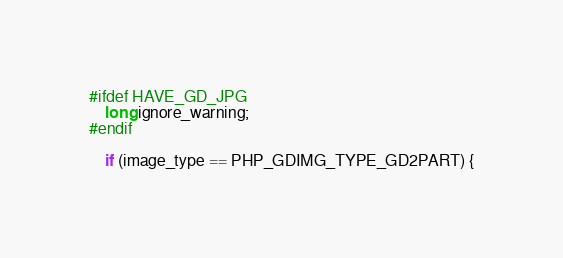<code> <loc_0><loc_0><loc_500><loc_500><_C_>#ifdef HAVE_GD_JPG
	long ignore_warning;
#endif

	if (image_type == PHP_GDIMG_TYPE_GD2PART) {</code> 